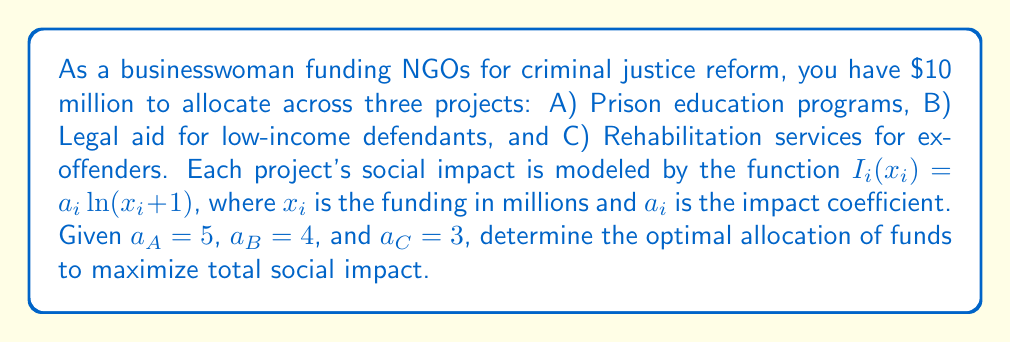Teach me how to tackle this problem. To solve this problem, we'll use the method of Lagrange multipliers to maximize the total social impact subject to the budget constraint.

1) The objective function (total social impact) is:
   $$I_{total} = 5\ln(x_A + 1) + 4\ln(x_B + 1) + 3\ln(x_C + 1)$$

2) The constraint is:
   $$x_A + x_B + x_C = 10$$

3) Form the Lagrangian:
   $$L = 5\ln(x_A + 1) + 4\ln(x_B + 1) + 3\ln(x_C + 1) - \lambda(x_A + x_B + x_C - 10)$$

4) Take partial derivatives and set them to zero:
   $$\frac{\partial L}{\partial x_A} = \frac{5}{x_A + 1} - \lambda = 0$$
   $$\frac{\partial L}{\partial x_B} = \frac{4}{x_B + 1} - \lambda = 0$$
   $$\frac{\partial L}{\partial x_C} = \frac{3}{x_C + 1} - \lambda = 0$$
   $$\frac{\partial L}{\partial \lambda} = x_A + x_B + x_C - 10 = 0$$

5) From these equations, we can deduce:
   $$\frac{5}{x_A + 1} = \frac{4}{x_B + 1} = \frac{3}{x_C + 1} = \lambda$$

6) This implies:
   $$x_A + 1 = \frac{5}{\lambda}, x_B + 1 = \frac{4}{\lambda}, x_C + 1 = \frac{3}{\lambda}$$

7) Substituting into the constraint equation:
   $$(\frac{5}{\lambda} - 1) + (\frac{4}{\lambda} - 1) + (\frac{3}{\lambda} - 1) = 10$$
   $$\frac{12}{\lambda} - 3 = 10$$
   $$\frac{12}{\lambda} = 13$$
   $$\lambda = \frac{12}{13}$$

8) Now we can solve for $x_A$, $x_B$, and $x_C$:
   $$x_A = \frac{5}{\lambda} - 1 = \frac{5 \cdot 13}{12} - 1 = \frac{65}{12} - 1 = \frac{53}{12} \approx 4.42$$
   $$x_B = \frac{4}{\lambda} - 1 = \frac{4 \cdot 13}{12} - 1 = \frac{52}{12} - 1 = \frac{40}{12} \approx 3.33$$
   $$x_C = \frac{3}{\lambda} - 1 = \frac{3 \cdot 13}{12} - 1 = \frac{39}{12} - 1 = \frac{27}{12} = 2.25$$
Answer: The optimal allocation of funds to maximize social impact is:
Project A (Prison education): $\frac{53}{12}$ million ≈ $4.42 million
Project B (Legal aid): $\frac{40}{12}$ million ≈ $3.33 million
Project C (Rehabilitation): $\frac{27}{12}$ million = $2.25 million 